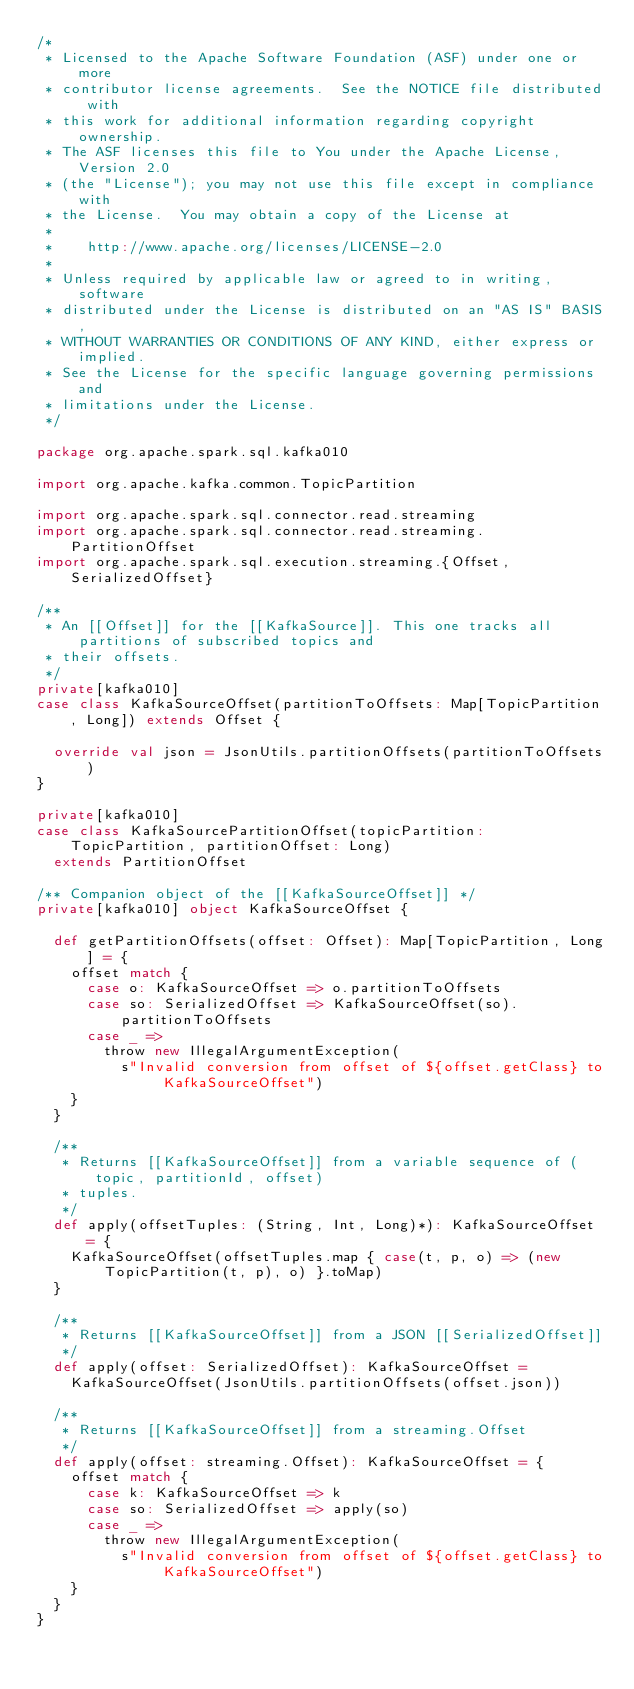<code> <loc_0><loc_0><loc_500><loc_500><_Scala_>/*
 * Licensed to the Apache Software Foundation (ASF) under one or more
 * contributor license agreements.  See the NOTICE file distributed with
 * this work for additional information regarding copyright ownership.
 * The ASF licenses this file to You under the Apache License, Version 2.0
 * (the "License"); you may not use this file except in compliance with
 * the License.  You may obtain a copy of the License at
 *
 *    http://www.apache.org/licenses/LICENSE-2.0
 *
 * Unless required by applicable law or agreed to in writing, software
 * distributed under the License is distributed on an "AS IS" BASIS,
 * WITHOUT WARRANTIES OR CONDITIONS OF ANY KIND, either express or implied.
 * See the License for the specific language governing permissions and
 * limitations under the License.
 */

package org.apache.spark.sql.kafka010

import org.apache.kafka.common.TopicPartition

import org.apache.spark.sql.connector.read.streaming
import org.apache.spark.sql.connector.read.streaming.PartitionOffset
import org.apache.spark.sql.execution.streaming.{Offset, SerializedOffset}

/**
 * An [[Offset]] for the [[KafkaSource]]. This one tracks all partitions of subscribed topics and
 * their offsets.
 */
private[kafka010]
case class KafkaSourceOffset(partitionToOffsets: Map[TopicPartition, Long]) extends Offset {

  override val json = JsonUtils.partitionOffsets(partitionToOffsets)
}

private[kafka010]
case class KafkaSourcePartitionOffset(topicPartition: TopicPartition, partitionOffset: Long)
  extends PartitionOffset

/** Companion object of the [[KafkaSourceOffset]] */
private[kafka010] object KafkaSourceOffset {

  def getPartitionOffsets(offset: Offset): Map[TopicPartition, Long] = {
    offset match {
      case o: KafkaSourceOffset => o.partitionToOffsets
      case so: SerializedOffset => KafkaSourceOffset(so).partitionToOffsets
      case _ =>
        throw new IllegalArgumentException(
          s"Invalid conversion from offset of ${offset.getClass} to KafkaSourceOffset")
    }
  }

  /**
   * Returns [[KafkaSourceOffset]] from a variable sequence of (topic, partitionId, offset)
   * tuples.
   */
  def apply(offsetTuples: (String, Int, Long)*): KafkaSourceOffset = {
    KafkaSourceOffset(offsetTuples.map { case(t, p, o) => (new TopicPartition(t, p), o) }.toMap)
  }

  /**
   * Returns [[KafkaSourceOffset]] from a JSON [[SerializedOffset]]
   */
  def apply(offset: SerializedOffset): KafkaSourceOffset =
    KafkaSourceOffset(JsonUtils.partitionOffsets(offset.json))

  /**
   * Returns [[KafkaSourceOffset]] from a streaming.Offset
   */
  def apply(offset: streaming.Offset): KafkaSourceOffset = {
    offset match {
      case k: KafkaSourceOffset => k
      case so: SerializedOffset => apply(so)
      case _ =>
        throw new IllegalArgumentException(
          s"Invalid conversion from offset of ${offset.getClass} to KafkaSourceOffset")
    }
  }
}
</code> 